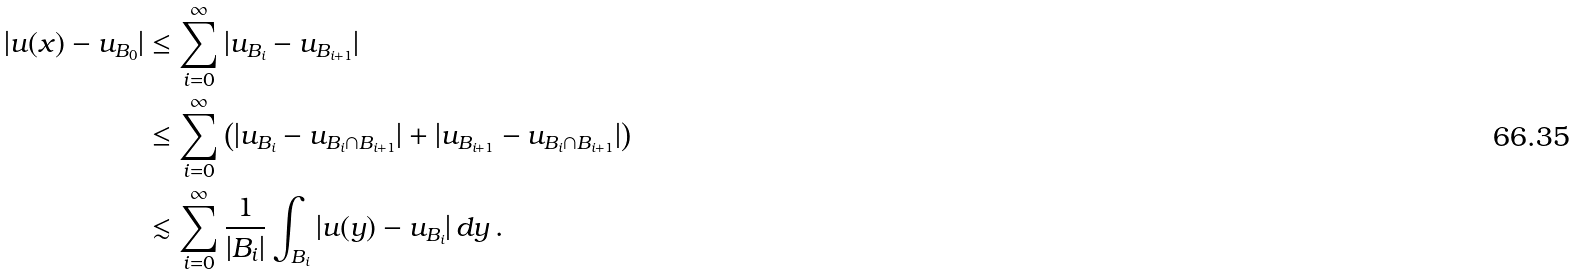Convert formula to latex. <formula><loc_0><loc_0><loc_500><loc_500>| u ( x ) - u _ { B _ { 0 } } | & \leq \sum _ { i = 0 } ^ { \infty } | u _ { B _ { i } } - u _ { B _ { i + 1 } } | \\ & \leq \sum _ { i = 0 } ^ { \infty } \left ( | u _ { B _ { i } } - u _ { B _ { i } \cap B _ { i + 1 } } | + | u _ { B _ { i + 1 } } - u _ { B _ { i } \cap B _ { i + 1 } } | \right ) \\ & \lesssim \sum _ { i = 0 } ^ { \infty } \frac { 1 } { | B _ { i } | } \int _ { B _ { i } } | u ( y ) - u _ { B _ { i } } | \, d y \, .</formula> 